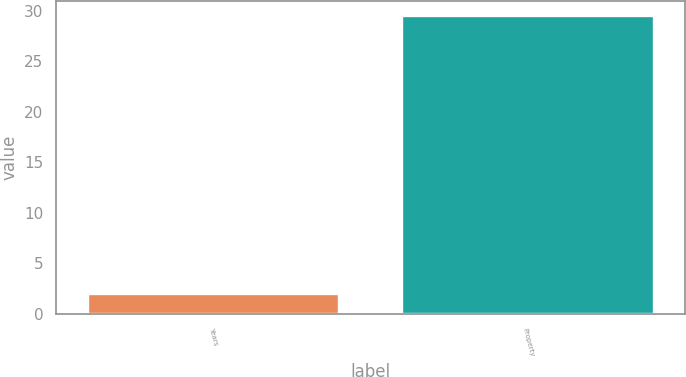<chart> <loc_0><loc_0><loc_500><loc_500><bar_chart><fcel>Years<fcel>Property<nl><fcel>2<fcel>29.5<nl></chart> 